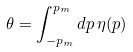Convert formula to latex. <formula><loc_0><loc_0><loc_500><loc_500>\theta = \int _ { - p _ { m } } ^ { p _ { m } } d p \, \eta ( p )</formula> 